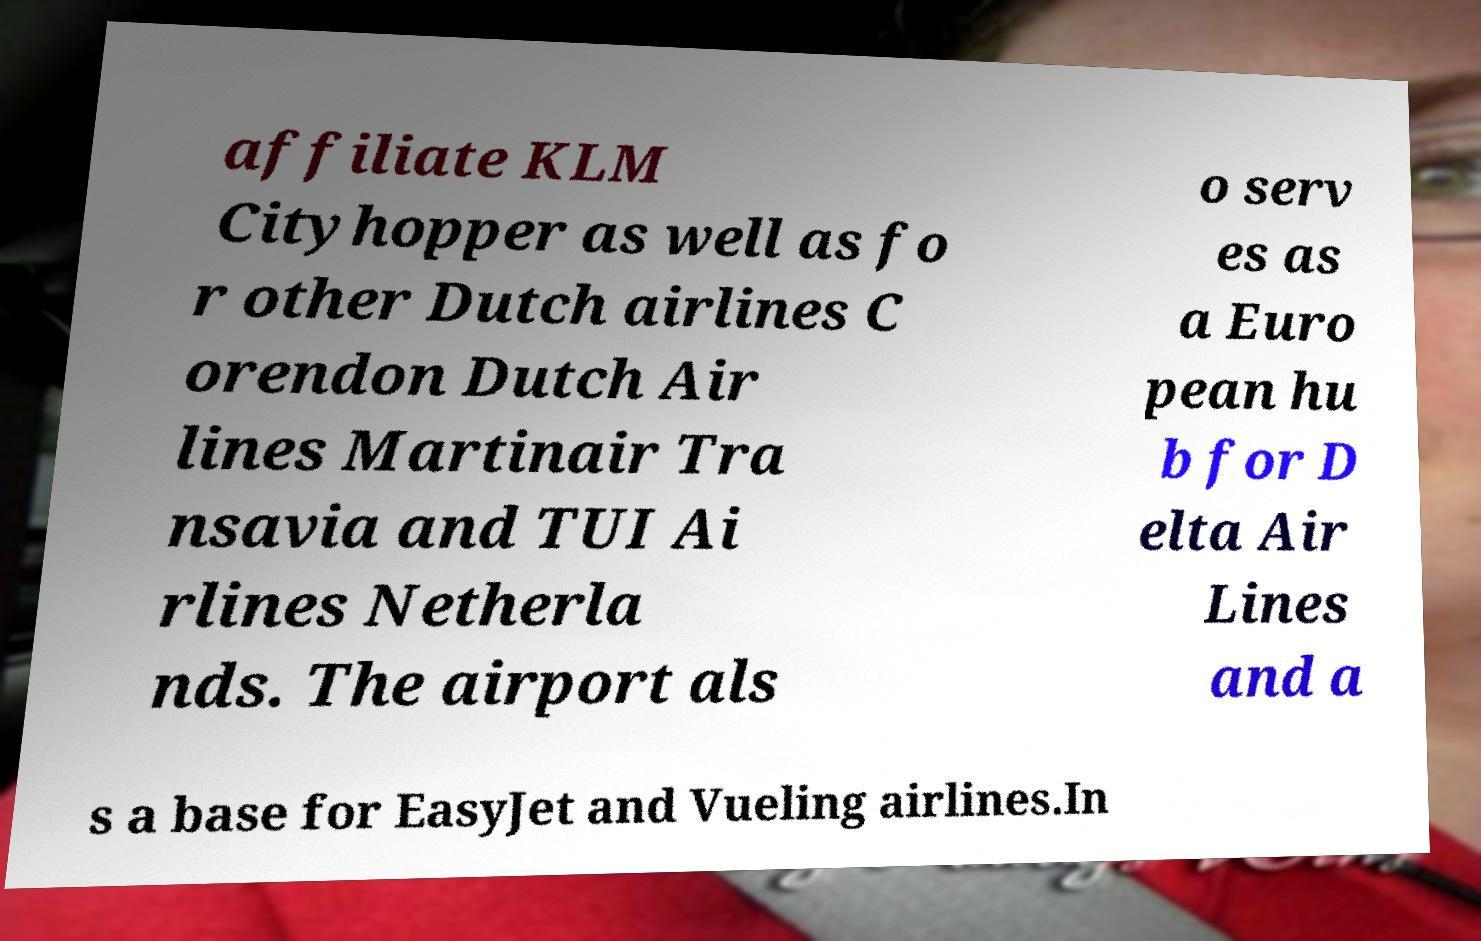For documentation purposes, I need the text within this image transcribed. Could you provide that? affiliate KLM Cityhopper as well as fo r other Dutch airlines C orendon Dutch Air lines Martinair Tra nsavia and TUI Ai rlines Netherla nds. The airport als o serv es as a Euro pean hu b for D elta Air Lines and a s a base for EasyJet and Vueling airlines.In 